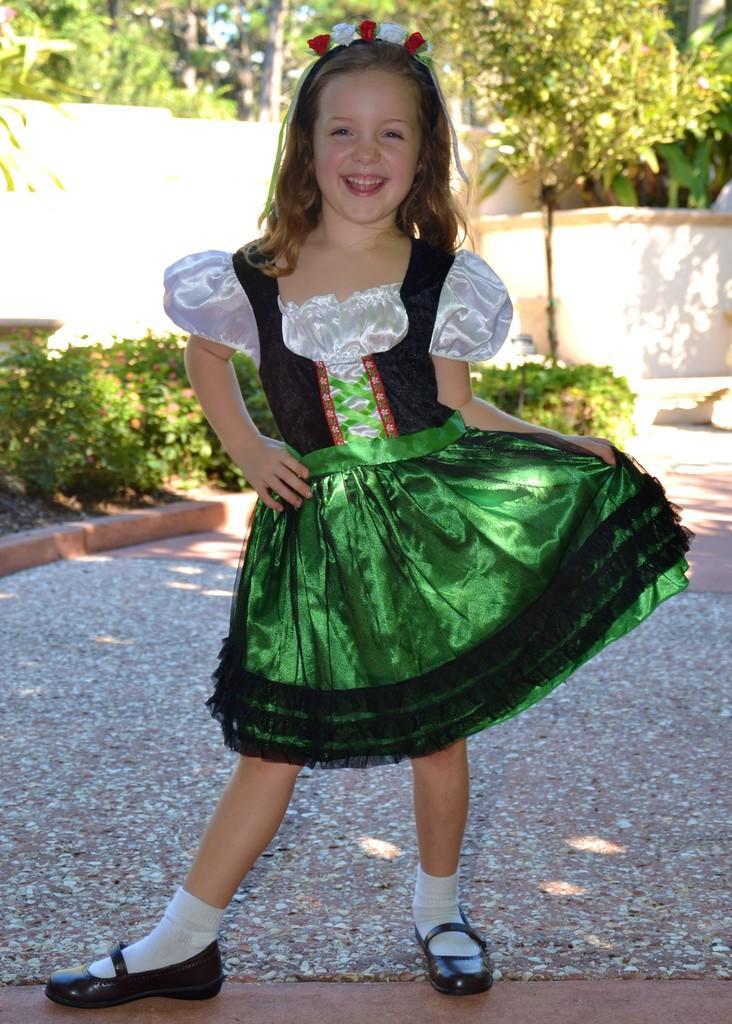Describe this image in one or two sentences. In this image I can see a person standing. She is wearing green,black and white dress and black shoe. Background I can see trees and wall. 